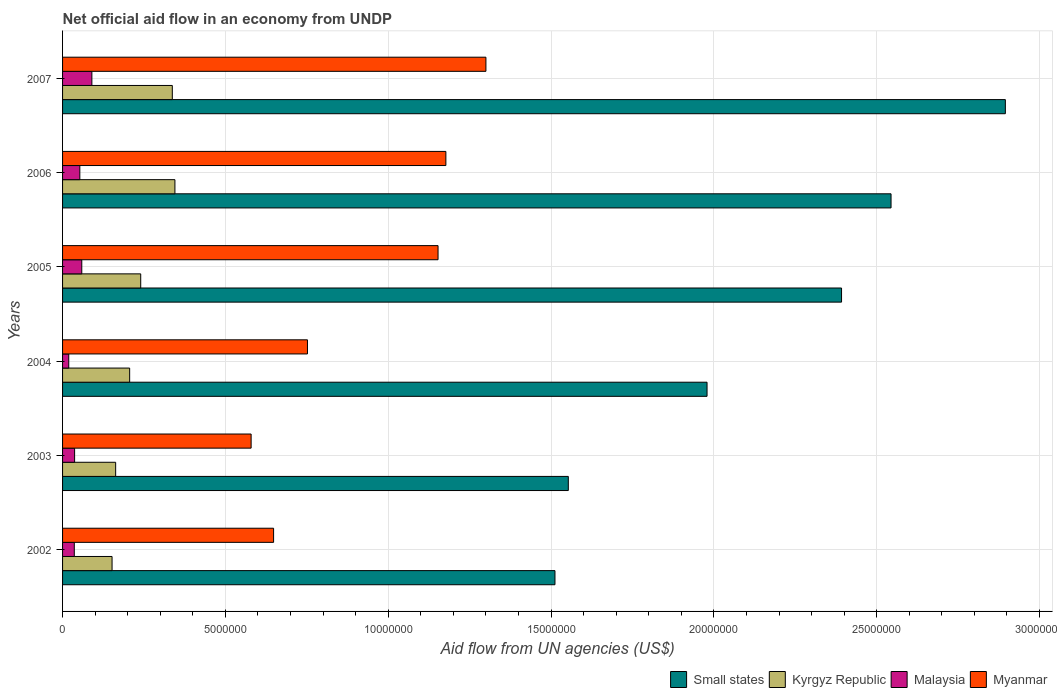How many bars are there on the 6th tick from the top?
Keep it short and to the point. 4. What is the label of the 6th group of bars from the top?
Provide a short and direct response. 2002. In how many cases, is the number of bars for a given year not equal to the number of legend labels?
Give a very brief answer. 0. What is the net official aid flow in Myanmar in 2003?
Provide a succinct answer. 5.79e+06. Across all years, what is the maximum net official aid flow in Kyrgyz Republic?
Your answer should be very brief. 3.45e+06. Across all years, what is the minimum net official aid flow in Kyrgyz Republic?
Offer a terse response. 1.52e+06. In which year was the net official aid flow in Small states maximum?
Your answer should be very brief. 2007. In which year was the net official aid flow in Kyrgyz Republic minimum?
Your answer should be compact. 2002. What is the total net official aid flow in Malaysia in the graph?
Keep it short and to the point. 2.94e+06. What is the difference between the net official aid flow in Kyrgyz Republic in 2004 and that in 2007?
Offer a very short reply. -1.31e+06. What is the difference between the net official aid flow in Malaysia in 2005 and the net official aid flow in Myanmar in 2003?
Offer a very short reply. -5.20e+06. In the year 2003, what is the difference between the net official aid flow in Malaysia and net official aid flow in Small states?
Make the answer very short. -1.52e+07. In how many years, is the net official aid flow in Myanmar greater than 25000000 US$?
Provide a short and direct response. 0. What is the ratio of the net official aid flow in Kyrgyz Republic in 2005 to that in 2006?
Your answer should be very brief. 0.7. Is the net official aid flow in Myanmar in 2003 less than that in 2004?
Keep it short and to the point. Yes. What is the difference between the highest and the second highest net official aid flow in Myanmar?
Your answer should be compact. 1.23e+06. What is the difference between the highest and the lowest net official aid flow in Kyrgyz Republic?
Ensure brevity in your answer.  1.93e+06. Is the sum of the net official aid flow in Malaysia in 2003 and 2006 greater than the maximum net official aid flow in Kyrgyz Republic across all years?
Give a very brief answer. No. What does the 3rd bar from the top in 2005 represents?
Give a very brief answer. Kyrgyz Republic. What does the 1st bar from the bottom in 2006 represents?
Make the answer very short. Small states. Is it the case that in every year, the sum of the net official aid flow in Small states and net official aid flow in Kyrgyz Republic is greater than the net official aid flow in Myanmar?
Give a very brief answer. Yes. How many bars are there?
Keep it short and to the point. 24. What is the difference between two consecutive major ticks on the X-axis?
Give a very brief answer. 5.00e+06. Does the graph contain any zero values?
Your response must be concise. No. Does the graph contain grids?
Provide a succinct answer. Yes. What is the title of the graph?
Make the answer very short. Net official aid flow in an economy from UNDP. What is the label or title of the X-axis?
Provide a short and direct response. Aid flow from UN agencies (US$). What is the label or title of the Y-axis?
Ensure brevity in your answer.  Years. What is the Aid flow from UN agencies (US$) of Small states in 2002?
Offer a terse response. 1.51e+07. What is the Aid flow from UN agencies (US$) of Kyrgyz Republic in 2002?
Make the answer very short. 1.52e+06. What is the Aid flow from UN agencies (US$) in Malaysia in 2002?
Offer a very short reply. 3.60e+05. What is the Aid flow from UN agencies (US$) in Myanmar in 2002?
Give a very brief answer. 6.48e+06. What is the Aid flow from UN agencies (US$) of Small states in 2003?
Provide a succinct answer. 1.55e+07. What is the Aid flow from UN agencies (US$) of Kyrgyz Republic in 2003?
Provide a short and direct response. 1.63e+06. What is the Aid flow from UN agencies (US$) in Myanmar in 2003?
Give a very brief answer. 5.79e+06. What is the Aid flow from UN agencies (US$) of Small states in 2004?
Your answer should be compact. 1.98e+07. What is the Aid flow from UN agencies (US$) in Kyrgyz Republic in 2004?
Give a very brief answer. 2.06e+06. What is the Aid flow from UN agencies (US$) in Malaysia in 2004?
Ensure brevity in your answer.  1.90e+05. What is the Aid flow from UN agencies (US$) of Myanmar in 2004?
Provide a succinct answer. 7.52e+06. What is the Aid flow from UN agencies (US$) in Small states in 2005?
Ensure brevity in your answer.  2.39e+07. What is the Aid flow from UN agencies (US$) in Kyrgyz Republic in 2005?
Offer a terse response. 2.40e+06. What is the Aid flow from UN agencies (US$) in Malaysia in 2005?
Offer a very short reply. 5.90e+05. What is the Aid flow from UN agencies (US$) of Myanmar in 2005?
Your answer should be compact. 1.15e+07. What is the Aid flow from UN agencies (US$) in Small states in 2006?
Give a very brief answer. 2.54e+07. What is the Aid flow from UN agencies (US$) of Kyrgyz Republic in 2006?
Provide a short and direct response. 3.45e+06. What is the Aid flow from UN agencies (US$) of Malaysia in 2006?
Your response must be concise. 5.30e+05. What is the Aid flow from UN agencies (US$) in Myanmar in 2006?
Offer a terse response. 1.18e+07. What is the Aid flow from UN agencies (US$) of Small states in 2007?
Your response must be concise. 2.90e+07. What is the Aid flow from UN agencies (US$) in Kyrgyz Republic in 2007?
Your response must be concise. 3.37e+06. What is the Aid flow from UN agencies (US$) in Malaysia in 2007?
Keep it short and to the point. 9.00e+05. What is the Aid flow from UN agencies (US$) in Myanmar in 2007?
Your answer should be compact. 1.30e+07. Across all years, what is the maximum Aid flow from UN agencies (US$) of Small states?
Your answer should be very brief. 2.90e+07. Across all years, what is the maximum Aid flow from UN agencies (US$) in Kyrgyz Republic?
Give a very brief answer. 3.45e+06. Across all years, what is the maximum Aid flow from UN agencies (US$) of Myanmar?
Offer a terse response. 1.30e+07. Across all years, what is the minimum Aid flow from UN agencies (US$) in Small states?
Offer a terse response. 1.51e+07. Across all years, what is the minimum Aid flow from UN agencies (US$) in Kyrgyz Republic?
Your response must be concise. 1.52e+06. Across all years, what is the minimum Aid flow from UN agencies (US$) in Myanmar?
Give a very brief answer. 5.79e+06. What is the total Aid flow from UN agencies (US$) of Small states in the graph?
Make the answer very short. 1.29e+08. What is the total Aid flow from UN agencies (US$) in Kyrgyz Republic in the graph?
Provide a short and direct response. 1.44e+07. What is the total Aid flow from UN agencies (US$) of Malaysia in the graph?
Your response must be concise. 2.94e+06. What is the total Aid flow from UN agencies (US$) of Myanmar in the graph?
Keep it short and to the point. 5.61e+07. What is the difference between the Aid flow from UN agencies (US$) of Small states in 2002 and that in 2003?
Offer a very short reply. -4.10e+05. What is the difference between the Aid flow from UN agencies (US$) of Kyrgyz Republic in 2002 and that in 2003?
Offer a terse response. -1.10e+05. What is the difference between the Aid flow from UN agencies (US$) of Malaysia in 2002 and that in 2003?
Make the answer very short. -10000. What is the difference between the Aid flow from UN agencies (US$) in Myanmar in 2002 and that in 2003?
Your response must be concise. 6.90e+05. What is the difference between the Aid flow from UN agencies (US$) in Small states in 2002 and that in 2004?
Your answer should be very brief. -4.67e+06. What is the difference between the Aid flow from UN agencies (US$) of Kyrgyz Republic in 2002 and that in 2004?
Keep it short and to the point. -5.40e+05. What is the difference between the Aid flow from UN agencies (US$) of Myanmar in 2002 and that in 2004?
Offer a very short reply. -1.04e+06. What is the difference between the Aid flow from UN agencies (US$) in Small states in 2002 and that in 2005?
Your answer should be compact. -8.80e+06. What is the difference between the Aid flow from UN agencies (US$) in Kyrgyz Republic in 2002 and that in 2005?
Give a very brief answer. -8.80e+05. What is the difference between the Aid flow from UN agencies (US$) of Myanmar in 2002 and that in 2005?
Ensure brevity in your answer.  -5.05e+06. What is the difference between the Aid flow from UN agencies (US$) in Small states in 2002 and that in 2006?
Offer a very short reply. -1.03e+07. What is the difference between the Aid flow from UN agencies (US$) of Kyrgyz Republic in 2002 and that in 2006?
Offer a terse response. -1.93e+06. What is the difference between the Aid flow from UN agencies (US$) of Malaysia in 2002 and that in 2006?
Provide a succinct answer. -1.70e+05. What is the difference between the Aid flow from UN agencies (US$) in Myanmar in 2002 and that in 2006?
Make the answer very short. -5.29e+06. What is the difference between the Aid flow from UN agencies (US$) of Small states in 2002 and that in 2007?
Ensure brevity in your answer.  -1.38e+07. What is the difference between the Aid flow from UN agencies (US$) in Kyrgyz Republic in 2002 and that in 2007?
Ensure brevity in your answer.  -1.85e+06. What is the difference between the Aid flow from UN agencies (US$) in Malaysia in 2002 and that in 2007?
Offer a terse response. -5.40e+05. What is the difference between the Aid flow from UN agencies (US$) of Myanmar in 2002 and that in 2007?
Provide a succinct answer. -6.52e+06. What is the difference between the Aid flow from UN agencies (US$) of Small states in 2003 and that in 2004?
Give a very brief answer. -4.26e+06. What is the difference between the Aid flow from UN agencies (US$) of Kyrgyz Republic in 2003 and that in 2004?
Offer a terse response. -4.30e+05. What is the difference between the Aid flow from UN agencies (US$) of Myanmar in 2003 and that in 2004?
Offer a terse response. -1.73e+06. What is the difference between the Aid flow from UN agencies (US$) in Small states in 2003 and that in 2005?
Your answer should be very brief. -8.39e+06. What is the difference between the Aid flow from UN agencies (US$) in Kyrgyz Republic in 2003 and that in 2005?
Make the answer very short. -7.70e+05. What is the difference between the Aid flow from UN agencies (US$) in Myanmar in 2003 and that in 2005?
Your response must be concise. -5.74e+06. What is the difference between the Aid flow from UN agencies (US$) of Small states in 2003 and that in 2006?
Keep it short and to the point. -9.91e+06. What is the difference between the Aid flow from UN agencies (US$) of Kyrgyz Republic in 2003 and that in 2006?
Provide a succinct answer. -1.82e+06. What is the difference between the Aid flow from UN agencies (US$) of Myanmar in 2003 and that in 2006?
Your response must be concise. -5.98e+06. What is the difference between the Aid flow from UN agencies (US$) of Small states in 2003 and that in 2007?
Offer a very short reply. -1.34e+07. What is the difference between the Aid flow from UN agencies (US$) in Kyrgyz Republic in 2003 and that in 2007?
Make the answer very short. -1.74e+06. What is the difference between the Aid flow from UN agencies (US$) in Malaysia in 2003 and that in 2007?
Keep it short and to the point. -5.30e+05. What is the difference between the Aid flow from UN agencies (US$) of Myanmar in 2003 and that in 2007?
Provide a succinct answer. -7.21e+06. What is the difference between the Aid flow from UN agencies (US$) of Small states in 2004 and that in 2005?
Keep it short and to the point. -4.13e+06. What is the difference between the Aid flow from UN agencies (US$) of Malaysia in 2004 and that in 2005?
Provide a short and direct response. -4.00e+05. What is the difference between the Aid flow from UN agencies (US$) in Myanmar in 2004 and that in 2005?
Your response must be concise. -4.01e+06. What is the difference between the Aid flow from UN agencies (US$) of Small states in 2004 and that in 2006?
Your answer should be very brief. -5.65e+06. What is the difference between the Aid flow from UN agencies (US$) in Kyrgyz Republic in 2004 and that in 2006?
Your response must be concise. -1.39e+06. What is the difference between the Aid flow from UN agencies (US$) in Malaysia in 2004 and that in 2006?
Provide a short and direct response. -3.40e+05. What is the difference between the Aid flow from UN agencies (US$) of Myanmar in 2004 and that in 2006?
Make the answer very short. -4.25e+06. What is the difference between the Aid flow from UN agencies (US$) in Small states in 2004 and that in 2007?
Provide a short and direct response. -9.16e+06. What is the difference between the Aid flow from UN agencies (US$) of Kyrgyz Republic in 2004 and that in 2007?
Your answer should be compact. -1.31e+06. What is the difference between the Aid flow from UN agencies (US$) of Malaysia in 2004 and that in 2007?
Your answer should be compact. -7.10e+05. What is the difference between the Aid flow from UN agencies (US$) in Myanmar in 2004 and that in 2007?
Provide a short and direct response. -5.48e+06. What is the difference between the Aid flow from UN agencies (US$) of Small states in 2005 and that in 2006?
Ensure brevity in your answer.  -1.52e+06. What is the difference between the Aid flow from UN agencies (US$) in Kyrgyz Republic in 2005 and that in 2006?
Your answer should be very brief. -1.05e+06. What is the difference between the Aid flow from UN agencies (US$) in Malaysia in 2005 and that in 2006?
Your response must be concise. 6.00e+04. What is the difference between the Aid flow from UN agencies (US$) of Myanmar in 2005 and that in 2006?
Provide a short and direct response. -2.40e+05. What is the difference between the Aid flow from UN agencies (US$) in Small states in 2005 and that in 2007?
Offer a terse response. -5.03e+06. What is the difference between the Aid flow from UN agencies (US$) in Kyrgyz Republic in 2005 and that in 2007?
Your answer should be very brief. -9.70e+05. What is the difference between the Aid flow from UN agencies (US$) in Malaysia in 2005 and that in 2007?
Keep it short and to the point. -3.10e+05. What is the difference between the Aid flow from UN agencies (US$) of Myanmar in 2005 and that in 2007?
Give a very brief answer. -1.47e+06. What is the difference between the Aid flow from UN agencies (US$) of Small states in 2006 and that in 2007?
Provide a succinct answer. -3.51e+06. What is the difference between the Aid flow from UN agencies (US$) in Kyrgyz Republic in 2006 and that in 2007?
Ensure brevity in your answer.  8.00e+04. What is the difference between the Aid flow from UN agencies (US$) in Malaysia in 2006 and that in 2007?
Your answer should be very brief. -3.70e+05. What is the difference between the Aid flow from UN agencies (US$) of Myanmar in 2006 and that in 2007?
Your answer should be very brief. -1.23e+06. What is the difference between the Aid flow from UN agencies (US$) in Small states in 2002 and the Aid flow from UN agencies (US$) in Kyrgyz Republic in 2003?
Provide a succinct answer. 1.35e+07. What is the difference between the Aid flow from UN agencies (US$) in Small states in 2002 and the Aid flow from UN agencies (US$) in Malaysia in 2003?
Offer a very short reply. 1.48e+07. What is the difference between the Aid flow from UN agencies (US$) in Small states in 2002 and the Aid flow from UN agencies (US$) in Myanmar in 2003?
Keep it short and to the point. 9.33e+06. What is the difference between the Aid flow from UN agencies (US$) in Kyrgyz Republic in 2002 and the Aid flow from UN agencies (US$) in Malaysia in 2003?
Ensure brevity in your answer.  1.15e+06. What is the difference between the Aid flow from UN agencies (US$) of Kyrgyz Republic in 2002 and the Aid flow from UN agencies (US$) of Myanmar in 2003?
Provide a short and direct response. -4.27e+06. What is the difference between the Aid flow from UN agencies (US$) of Malaysia in 2002 and the Aid flow from UN agencies (US$) of Myanmar in 2003?
Offer a terse response. -5.43e+06. What is the difference between the Aid flow from UN agencies (US$) of Small states in 2002 and the Aid flow from UN agencies (US$) of Kyrgyz Republic in 2004?
Your response must be concise. 1.31e+07. What is the difference between the Aid flow from UN agencies (US$) in Small states in 2002 and the Aid flow from UN agencies (US$) in Malaysia in 2004?
Your answer should be very brief. 1.49e+07. What is the difference between the Aid flow from UN agencies (US$) in Small states in 2002 and the Aid flow from UN agencies (US$) in Myanmar in 2004?
Your response must be concise. 7.60e+06. What is the difference between the Aid flow from UN agencies (US$) in Kyrgyz Republic in 2002 and the Aid flow from UN agencies (US$) in Malaysia in 2004?
Ensure brevity in your answer.  1.33e+06. What is the difference between the Aid flow from UN agencies (US$) in Kyrgyz Republic in 2002 and the Aid flow from UN agencies (US$) in Myanmar in 2004?
Provide a short and direct response. -6.00e+06. What is the difference between the Aid flow from UN agencies (US$) in Malaysia in 2002 and the Aid flow from UN agencies (US$) in Myanmar in 2004?
Your answer should be very brief. -7.16e+06. What is the difference between the Aid flow from UN agencies (US$) of Small states in 2002 and the Aid flow from UN agencies (US$) of Kyrgyz Republic in 2005?
Offer a terse response. 1.27e+07. What is the difference between the Aid flow from UN agencies (US$) of Small states in 2002 and the Aid flow from UN agencies (US$) of Malaysia in 2005?
Your answer should be very brief. 1.45e+07. What is the difference between the Aid flow from UN agencies (US$) of Small states in 2002 and the Aid flow from UN agencies (US$) of Myanmar in 2005?
Your response must be concise. 3.59e+06. What is the difference between the Aid flow from UN agencies (US$) of Kyrgyz Republic in 2002 and the Aid flow from UN agencies (US$) of Malaysia in 2005?
Keep it short and to the point. 9.30e+05. What is the difference between the Aid flow from UN agencies (US$) of Kyrgyz Republic in 2002 and the Aid flow from UN agencies (US$) of Myanmar in 2005?
Provide a short and direct response. -1.00e+07. What is the difference between the Aid flow from UN agencies (US$) in Malaysia in 2002 and the Aid flow from UN agencies (US$) in Myanmar in 2005?
Offer a terse response. -1.12e+07. What is the difference between the Aid flow from UN agencies (US$) of Small states in 2002 and the Aid flow from UN agencies (US$) of Kyrgyz Republic in 2006?
Give a very brief answer. 1.17e+07. What is the difference between the Aid flow from UN agencies (US$) in Small states in 2002 and the Aid flow from UN agencies (US$) in Malaysia in 2006?
Offer a terse response. 1.46e+07. What is the difference between the Aid flow from UN agencies (US$) of Small states in 2002 and the Aid flow from UN agencies (US$) of Myanmar in 2006?
Make the answer very short. 3.35e+06. What is the difference between the Aid flow from UN agencies (US$) of Kyrgyz Republic in 2002 and the Aid flow from UN agencies (US$) of Malaysia in 2006?
Offer a terse response. 9.90e+05. What is the difference between the Aid flow from UN agencies (US$) of Kyrgyz Republic in 2002 and the Aid flow from UN agencies (US$) of Myanmar in 2006?
Provide a short and direct response. -1.02e+07. What is the difference between the Aid flow from UN agencies (US$) in Malaysia in 2002 and the Aid flow from UN agencies (US$) in Myanmar in 2006?
Give a very brief answer. -1.14e+07. What is the difference between the Aid flow from UN agencies (US$) in Small states in 2002 and the Aid flow from UN agencies (US$) in Kyrgyz Republic in 2007?
Your answer should be very brief. 1.18e+07. What is the difference between the Aid flow from UN agencies (US$) of Small states in 2002 and the Aid flow from UN agencies (US$) of Malaysia in 2007?
Provide a short and direct response. 1.42e+07. What is the difference between the Aid flow from UN agencies (US$) in Small states in 2002 and the Aid flow from UN agencies (US$) in Myanmar in 2007?
Keep it short and to the point. 2.12e+06. What is the difference between the Aid flow from UN agencies (US$) of Kyrgyz Republic in 2002 and the Aid flow from UN agencies (US$) of Malaysia in 2007?
Make the answer very short. 6.20e+05. What is the difference between the Aid flow from UN agencies (US$) of Kyrgyz Republic in 2002 and the Aid flow from UN agencies (US$) of Myanmar in 2007?
Your answer should be compact. -1.15e+07. What is the difference between the Aid flow from UN agencies (US$) in Malaysia in 2002 and the Aid flow from UN agencies (US$) in Myanmar in 2007?
Your response must be concise. -1.26e+07. What is the difference between the Aid flow from UN agencies (US$) in Small states in 2003 and the Aid flow from UN agencies (US$) in Kyrgyz Republic in 2004?
Give a very brief answer. 1.35e+07. What is the difference between the Aid flow from UN agencies (US$) in Small states in 2003 and the Aid flow from UN agencies (US$) in Malaysia in 2004?
Your response must be concise. 1.53e+07. What is the difference between the Aid flow from UN agencies (US$) in Small states in 2003 and the Aid flow from UN agencies (US$) in Myanmar in 2004?
Offer a very short reply. 8.01e+06. What is the difference between the Aid flow from UN agencies (US$) in Kyrgyz Republic in 2003 and the Aid flow from UN agencies (US$) in Malaysia in 2004?
Provide a short and direct response. 1.44e+06. What is the difference between the Aid flow from UN agencies (US$) in Kyrgyz Republic in 2003 and the Aid flow from UN agencies (US$) in Myanmar in 2004?
Offer a very short reply. -5.89e+06. What is the difference between the Aid flow from UN agencies (US$) in Malaysia in 2003 and the Aid flow from UN agencies (US$) in Myanmar in 2004?
Offer a terse response. -7.15e+06. What is the difference between the Aid flow from UN agencies (US$) of Small states in 2003 and the Aid flow from UN agencies (US$) of Kyrgyz Republic in 2005?
Your answer should be very brief. 1.31e+07. What is the difference between the Aid flow from UN agencies (US$) in Small states in 2003 and the Aid flow from UN agencies (US$) in Malaysia in 2005?
Your answer should be very brief. 1.49e+07. What is the difference between the Aid flow from UN agencies (US$) in Kyrgyz Republic in 2003 and the Aid flow from UN agencies (US$) in Malaysia in 2005?
Your response must be concise. 1.04e+06. What is the difference between the Aid flow from UN agencies (US$) of Kyrgyz Republic in 2003 and the Aid flow from UN agencies (US$) of Myanmar in 2005?
Provide a short and direct response. -9.90e+06. What is the difference between the Aid flow from UN agencies (US$) of Malaysia in 2003 and the Aid flow from UN agencies (US$) of Myanmar in 2005?
Ensure brevity in your answer.  -1.12e+07. What is the difference between the Aid flow from UN agencies (US$) in Small states in 2003 and the Aid flow from UN agencies (US$) in Kyrgyz Republic in 2006?
Give a very brief answer. 1.21e+07. What is the difference between the Aid flow from UN agencies (US$) of Small states in 2003 and the Aid flow from UN agencies (US$) of Malaysia in 2006?
Give a very brief answer. 1.50e+07. What is the difference between the Aid flow from UN agencies (US$) in Small states in 2003 and the Aid flow from UN agencies (US$) in Myanmar in 2006?
Your response must be concise. 3.76e+06. What is the difference between the Aid flow from UN agencies (US$) in Kyrgyz Republic in 2003 and the Aid flow from UN agencies (US$) in Malaysia in 2006?
Ensure brevity in your answer.  1.10e+06. What is the difference between the Aid flow from UN agencies (US$) of Kyrgyz Republic in 2003 and the Aid flow from UN agencies (US$) of Myanmar in 2006?
Ensure brevity in your answer.  -1.01e+07. What is the difference between the Aid flow from UN agencies (US$) of Malaysia in 2003 and the Aid flow from UN agencies (US$) of Myanmar in 2006?
Your response must be concise. -1.14e+07. What is the difference between the Aid flow from UN agencies (US$) of Small states in 2003 and the Aid flow from UN agencies (US$) of Kyrgyz Republic in 2007?
Provide a succinct answer. 1.22e+07. What is the difference between the Aid flow from UN agencies (US$) of Small states in 2003 and the Aid flow from UN agencies (US$) of Malaysia in 2007?
Your answer should be very brief. 1.46e+07. What is the difference between the Aid flow from UN agencies (US$) in Small states in 2003 and the Aid flow from UN agencies (US$) in Myanmar in 2007?
Give a very brief answer. 2.53e+06. What is the difference between the Aid flow from UN agencies (US$) of Kyrgyz Republic in 2003 and the Aid flow from UN agencies (US$) of Malaysia in 2007?
Offer a very short reply. 7.30e+05. What is the difference between the Aid flow from UN agencies (US$) in Kyrgyz Republic in 2003 and the Aid flow from UN agencies (US$) in Myanmar in 2007?
Ensure brevity in your answer.  -1.14e+07. What is the difference between the Aid flow from UN agencies (US$) in Malaysia in 2003 and the Aid flow from UN agencies (US$) in Myanmar in 2007?
Offer a terse response. -1.26e+07. What is the difference between the Aid flow from UN agencies (US$) in Small states in 2004 and the Aid flow from UN agencies (US$) in Kyrgyz Republic in 2005?
Make the answer very short. 1.74e+07. What is the difference between the Aid flow from UN agencies (US$) of Small states in 2004 and the Aid flow from UN agencies (US$) of Malaysia in 2005?
Offer a very short reply. 1.92e+07. What is the difference between the Aid flow from UN agencies (US$) in Small states in 2004 and the Aid flow from UN agencies (US$) in Myanmar in 2005?
Keep it short and to the point. 8.26e+06. What is the difference between the Aid flow from UN agencies (US$) in Kyrgyz Republic in 2004 and the Aid flow from UN agencies (US$) in Malaysia in 2005?
Offer a terse response. 1.47e+06. What is the difference between the Aid flow from UN agencies (US$) of Kyrgyz Republic in 2004 and the Aid flow from UN agencies (US$) of Myanmar in 2005?
Your answer should be compact. -9.47e+06. What is the difference between the Aid flow from UN agencies (US$) of Malaysia in 2004 and the Aid flow from UN agencies (US$) of Myanmar in 2005?
Make the answer very short. -1.13e+07. What is the difference between the Aid flow from UN agencies (US$) in Small states in 2004 and the Aid flow from UN agencies (US$) in Kyrgyz Republic in 2006?
Keep it short and to the point. 1.63e+07. What is the difference between the Aid flow from UN agencies (US$) of Small states in 2004 and the Aid flow from UN agencies (US$) of Malaysia in 2006?
Give a very brief answer. 1.93e+07. What is the difference between the Aid flow from UN agencies (US$) in Small states in 2004 and the Aid flow from UN agencies (US$) in Myanmar in 2006?
Provide a succinct answer. 8.02e+06. What is the difference between the Aid flow from UN agencies (US$) of Kyrgyz Republic in 2004 and the Aid flow from UN agencies (US$) of Malaysia in 2006?
Offer a terse response. 1.53e+06. What is the difference between the Aid flow from UN agencies (US$) of Kyrgyz Republic in 2004 and the Aid flow from UN agencies (US$) of Myanmar in 2006?
Provide a short and direct response. -9.71e+06. What is the difference between the Aid flow from UN agencies (US$) in Malaysia in 2004 and the Aid flow from UN agencies (US$) in Myanmar in 2006?
Offer a very short reply. -1.16e+07. What is the difference between the Aid flow from UN agencies (US$) of Small states in 2004 and the Aid flow from UN agencies (US$) of Kyrgyz Republic in 2007?
Offer a very short reply. 1.64e+07. What is the difference between the Aid flow from UN agencies (US$) in Small states in 2004 and the Aid flow from UN agencies (US$) in Malaysia in 2007?
Offer a terse response. 1.89e+07. What is the difference between the Aid flow from UN agencies (US$) of Small states in 2004 and the Aid flow from UN agencies (US$) of Myanmar in 2007?
Offer a terse response. 6.79e+06. What is the difference between the Aid flow from UN agencies (US$) in Kyrgyz Republic in 2004 and the Aid flow from UN agencies (US$) in Malaysia in 2007?
Provide a short and direct response. 1.16e+06. What is the difference between the Aid flow from UN agencies (US$) of Kyrgyz Republic in 2004 and the Aid flow from UN agencies (US$) of Myanmar in 2007?
Your answer should be very brief. -1.09e+07. What is the difference between the Aid flow from UN agencies (US$) in Malaysia in 2004 and the Aid flow from UN agencies (US$) in Myanmar in 2007?
Ensure brevity in your answer.  -1.28e+07. What is the difference between the Aid flow from UN agencies (US$) of Small states in 2005 and the Aid flow from UN agencies (US$) of Kyrgyz Republic in 2006?
Make the answer very short. 2.05e+07. What is the difference between the Aid flow from UN agencies (US$) of Small states in 2005 and the Aid flow from UN agencies (US$) of Malaysia in 2006?
Give a very brief answer. 2.34e+07. What is the difference between the Aid flow from UN agencies (US$) of Small states in 2005 and the Aid flow from UN agencies (US$) of Myanmar in 2006?
Your answer should be very brief. 1.22e+07. What is the difference between the Aid flow from UN agencies (US$) in Kyrgyz Republic in 2005 and the Aid flow from UN agencies (US$) in Malaysia in 2006?
Keep it short and to the point. 1.87e+06. What is the difference between the Aid flow from UN agencies (US$) of Kyrgyz Republic in 2005 and the Aid flow from UN agencies (US$) of Myanmar in 2006?
Your answer should be very brief. -9.37e+06. What is the difference between the Aid flow from UN agencies (US$) in Malaysia in 2005 and the Aid flow from UN agencies (US$) in Myanmar in 2006?
Your response must be concise. -1.12e+07. What is the difference between the Aid flow from UN agencies (US$) of Small states in 2005 and the Aid flow from UN agencies (US$) of Kyrgyz Republic in 2007?
Give a very brief answer. 2.06e+07. What is the difference between the Aid flow from UN agencies (US$) in Small states in 2005 and the Aid flow from UN agencies (US$) in Malaysia in 2007?
Your answer should be compact. 2.30e+07. What is the difference between the Aid flow from UN agencies (US$) in Small states in 2005 and the Aid flow from UN agencies (US$) in Myanmar in 2007?
Your answer should be compact. 1.09e+07. What is the difference between the Aid flow from UN agencies (US$) of Kyrgyz Republic in 2005 and the Aid flow from UN agencies (US$) of Malaysia in 2007?
Keep it short and to the point. 1.50e+06. What is the difference between the Aid flow from UN agencies (US$) of Kyrgyz Republic in 2005 and the Aid flow from UN agencies (US$) of Myanmar in 2007?
Your answer should be very brief. -1.06e+07. What is the difference between the Aid flow from UN agencies (US$) of Malaysia in 2005 and the Aid flow from UN agencies (US$) of Myanmar in 2007?
Offer a very short reply. -1.24e+07. What is the difference between the Aid flow from UN agencies (US$) of Small states in 2006 and the Aid flow from UN agencies (US$) of Kyrgyz Republic in 2007?
Keep it short and to the point. 2.21e+07. What is the difference between the Aid flow from UN agencies (US$) in Small states in 2006 and the Aid flow from UN agencies (US$) in Malaysia in 2007?
Keep it short and to the point. 2.45e+07. What is the difference between the Aid flow from UN agencies (US$) in Small states in 2006 and the Aid flow from UN agencies (US$) in Myanmar in 2007?
Provide a short and direct response. 1.24e+07. What is the difference between the Aid flow from UN agencies (US$) of Kyrgyz Republic in 2006 and the Aid flow from UN agencies (US$) of Malaysia in 2007?
Make the answer very short. 2.55e+06. What is the difference between the Aid flow from UN agencies (US$) of Kyrgyz Republic in 2006 and the Aid flow from UN agencies (US$) of Myanmar in 2007?
Offer a terse response. -9.55e+06. What is the difference between the Aid flow from UN agencies (US$) in Malaysia in 2006 and the Aid flow from UN agencies (US$) in Myanmar in 2007?
Ensure brevity in your answer.  -1.25e+07. What is the average Aid flow from UN agencies (US$) in Small states per year?
Give a very brief answer. 2.15e+07. What is the average Aid flow from UN agencies (US$) of Kyrgyz Republic per year?
Your answer should be compact. 2.40e+06. What is the average Aid flow from UN agencies (US$) in Myanmar per year?
Provide a short and direct response. 9.35e+06. In the year 2002, what is the difference between the Aid flow from UN agencies (US$) of Small states and Aid flow from UN agencies (US$) of Kyrgyz Republic?
Your answer should be very brief. 1.36e+07. In the year 2002, what is the difference between the Aid flow from UN agencies (US$) of Small states and Aid flow from UN agencies (US$) of Malaysia?
Offer a very short reply. 1.48e+07. In the year 2002, what is the difference between the Aid flow from UN agencies (US$) of Small states and Aid flow from UN agencies (US$) of Myanmar?
Your answer should be compact. 8.64e+06. In the year 2002, what is the difference between the Aid flow from UN agencies (US$) of Kyrgyz Republic and Aid flow from UN agencies (US$) of Malaysia?
Provide a short and direct response. 1.16e+06. In the year 2002, what is the difference between the Aid flow from UN agencies (US$) in Kyrgyz Republic and Aid flow from UN agencies (US$) in Myanmar?
Provide a succinct answer. -4.96e+06. In the year 2002, what is the difference between the Aid flow from UN agencies (US$) of Malaysia and Aid flow from UN agencies (US$) of Myanmar?
Keep it short and to the point. -6.12e+06. In the year 2003, what is the difference between the Aid flow from UN agencies (US$) in Small states and Aid flow from UN agencies (US$) in Kyrgyz Republic?
Keep it short and to the point. 1.39e+07. In the year 2003, what is the difference between the Aid flow from UN agencies (US$) of Small states and Aid flow from UN agencies (US$) of Malaysia?
Your answer should be very brief. 1.52e+07. In the year 2003, what is the difference between the Aid flow from UN agencies (US$) in Small states and Aid flow from UN agencies (US$) in Myanmar?
Make the answer very short. 9.74e+06. In the year 2003, what is the difference between the Aid flow from UN agencies (US$) in Kyrgyz Republic and Aid flow from UN agencies (US$) in Malaysia?
Offer a terse response. 1.26e+06. In the year 2003, what is the difference between the Aid flow from UN agencies (US$) of Kyrgyz Republic and Aid flow from UN agencies (US$) of Myanmar?
Your answer should be compact. -4.16e+06. In the year 2003, what is the difference between the Aid flow from UN agencies (US$) in Malaysia and Aid flow from UN agencies (US$) in Myanmar?
Offer a terse response. -5.42e+06. In the year 2004, what is the difference between the Aid flow from UN agencies (US$) of Small states and Aid flow from UN agencies (US$) of Kyrgyz Republic?
Keep it short and to the point. 1.77e+07. In the year 2004, what is the difference between the Aid flow from UN agencies (US$) of Small states and Aid flow from UN agencies (US$) of Malaysia?
Your response must be concise. 1.96e+07. In the year 2004, what is the difference between the Aid flow from UN agencies (US$) in Small states and Aid flow from UN agencies (US$) in Myanmar?
Provide a succinct answer. 1.23e+07. In the year 2004, what is the difference between the Aid flow from UN agencies (US$) of Kyrgyz Republic and Aid flow from UN agencies (US$) of Malaysia?
Give a very brief answer. 1.87e+06. In the year 2004, what is the difference between the Aid flow from UN agencies (US$) of Kyrgyz Republic and Aid flow from UN agencies (US$) of Myanmar?
Give a very brief answer. -5.46e+06. In the year 2004, what is the difference between the Aid flow from UN agencies (US$) of Malaysia and Aid flow from UN agencies (US$) of Myanmar?
Provide a succinct answer. -7.33e+06. In the year 2005, what is the difference between the Aid flow from UN agencies (US$) in Small states and Aid flow from UN agencies (US$) in Kyrgyz Republic?
Offer a terse response. 2.15e+07. In the year 2005, what is the difference between the Aid flow from UN agencies (US$) in Small states and Aid flow from UN agencies (US$) in Malaysia?
Offer a very short reply. 2.33e+07. In the year 2005, what is the difference between the Aid flow from UN agencies (US$) in Small states and Aid flow from UN agencies (US$) in Myanmar?
Provide a short and direct response. 1.24e+07. In the year 2005, what is the difference between the Aid flow from UN agencies (US$) in Kyrgyz Republic and Aid flow from UN agencies (US$) in Malaysia?
Your answer should be compact. 1.81e+06. In the year 2005, what is the difference between the Aid flow from UN agencies (US$) of Kyrgyz Republic and Aid flow from UN agencies (US$) of Myanmar?
Provide a short and direct response. -9.13e+06. In the year 2005, what is the difference between the Aid flow from UN agencies (US$) in Malaysia and Aid flow from UN agencies (US$) in Myanmar?
Provide a succinct answer. -1.09e+07. In the year 2006, what is the difference between the Aid flow from UN agencies (US$) of Small states and Aid flow from UN agencies (US$) of Kyrgyz Republic?
Your answer should be compact. 2.20e+07. In the year 2006, what is the difference between the Aid flow from UN agencies (US$) of Small states and Aid flow from UN agencies (US$) of Malaysia?
Offer a very short reply. 2.49e+07. In the year 2006, what is the difference between the Aid flow from UN agencies (US$) of Small states and Aid flow from UN agencies (US$) of Myanmar?
Make the answer very short. 1.37e+07. In the year 2006, what is the difference between the Aid flow from UN agencies (US$) of Kyrgyz Republic and Aid flow from UN agencies (US$) of Malaysia?
Offer a terse response. 2.92e+06. In the year 2006, what is the difference between the Aid flow from UN agencies (US$) in Kyrgyz Republic and Aid flow from UN agencies (US$) in Myanmar?
Offer a terse response. -8.32e+06. In the year 2006, what is the difference between the Aid flow from UN agencies (US$) in Malaysia and Aid flow from UN agencies (US$) in Myanmar?
Provide a succinct answer. -1.12e+07. In the year 2007, what is the difference between the Aid flow from UN agencies (US$) in Small states and Aid flow from UN agencies (US$) in Kyrgyz Republic?
Your answer should be compact. 2.56e+07. In the year 2007, what is the difference between the Aid flow from UN agencies (US$) in Small states and Aid flow from UN agencies (US$) in Malaysia?
Give a very brief answer. 2.80e+07. In the year 2007, what is the difference between the Aid flow from UN agencies (US$) of Small states and Aid flow from UN agencies (US$) of Myanmar?
Keep it short and to the point. 1.60e+07. In the year 2007, what is the difference between the Aid flow from UN agencies (US$) in Kyrgyz Republic and Aid flow from UN agencies (US$) in Malaysia?
Offer a terse response. 2.47e+06. In the year 2007, what is the difference between the Aid flow from UN agencies (US$) in Kyrgyz Republic and Aid flow from UN agencies (US$) in Myanmar?
Give a very brief answer. -9.63e+06. In the year 2007, what is the difference between the Aid flow from UN agencies (US$) in Malaysia and Aid flow from UN agencies (US$) in Myanmar?
Ensure brevity in your answer.  -1.21e+07. What is the ratio of the Aid flow from UN agencies (US$) in Small states in 2002 to that in 2003?
Your answer should be very brief. 0.97. What is the ratio of the Aid flow from UN agencies (US$) in Kyrgyz Republic in 2002 to that in 2003?
Provide a short and direct response. 0.93. What is the ratio of the Aid flow from UN agencies (US$) in Malaysia in 2002 to that in 2003?
Keep it short and to the point. 0.97. What is the ratio of the Aid flow from UN agencies (US$) in Myanmar in 2002 to that in 2003?
Ensure brevity in your answer.  1.12. What is the ratio of the Aid flow from UN agencies (US$) of Small states in 2002 to that in 2004?
Make the answer very short. 0.76. What is the ratio of the Aid flow from UN agencies (US$) in Kyrgyz Republic in 2002 to that in 2004?
Offer a very short reply. 0.74. What is the ratio of the Aid flow from UN agencies (US$) of Malaysia in 2002 to that in 2004?
Keep it short and to the point. 1.89. What is the ratio of the Aid flow from UN agencies (US$) of Myanmar in 2002 to that in 2004?
Your answer should be compact. 0.86. What is the ratio of the Aid flow from UN agencies (US$) in Small states in 2002 to that in 2005?
Offer a very short reply. 0.63. What is the ratio of the Aid flow from UN agencies (US$) in Kyrgyz Republic in 2002 to that in 2005?
Ensure brevity in your answer.  0.63. What is the ratio of the Aid flow from UN agencies (US$) of Malaysia in 2002 to that in 2005?
Offer a very short reply. 0.61. What is the ratio of the Aid flow from UN agencies (US$) in Myanmar in 2002 to that in 2005?
Your response must be concise. 0.56. What is the ratio of the Aid flow from UN agencies (US$) of Small states in 2002 to that in 2006?
Your answer should be compact. 0.59. What is the ratio of the Aid flow from UN agencies (US$) of Kyrgyz Republic in 2002 to that in 2006?
Your answer should be very brief. 0.44. What is the ratio of the Aid flow from UN agencies (US$) in Malaysia in 2002 to that in 2006?
Make the answer very short. 0.68. What is the ratio of the Aid flow from UN agencies (US$) of Myanmar in 2002 to that in 2006?
Provide a succinct answer. 0.55. What is the ratio of the Aid flow from UN agencies (US$) in Small states in 2002 to that in 2007?
Provide a succinct answer. 0.52. What is the ratio of the Aid flow from UN agencies (US$) in Kyrgyz Republic in 2002 to that in 2007?
Offer a very short reply. 0.45. What is the ratio of the Aid flow from UN agencies (US$) in Malaysia in 2002 to that in 2007?
Give a very brief answer. 0.4. What is the ratio of the Aid flow from UN agencies (US$) in Myanmar in 2002 to that in 2007?
Make the answer very short. 0.5. What is the ratio of the Aid flow from UN agencies (US$) of Small states in 2003 to that in 2004?
Provide a short and direct response. 0.78. What is the ratio of the Aid flow from UN agencies (US$) in Kyrgyz Republic in 2003 to that in 2004?
Offer a terse response. 0.79. What is the ratio of the Aid flow from UN agencies (US$) of Malaysia in 2003 to that in 2004?
Offer a terse response. 1.95. What is the ratio of the Aid flow from UN agencies (US$) in Myanmar in 2003 to that in 2004?
Provide a short and direct response. 0.77. What is the ratio of the Aid flow from UN agencies (US$) of Small states in 2003 to that in 2005?
Provide a short and direct response. 0.65. What is the ratio of the Aid flow from UN agencies (US$) of Kyrgyz Republic in 2003 to that in 2005?
Provide a short and direct response. 0.68. What is the ratio of the Aid flow from UN agencies (US$) of Malaysia in 2003 to that in 2005?
Provide a short and direct response. 0.63. What is the ratio of the Aid flow from UN agencies (US$) of Myanmar in 2003 to that in 2005?
Your answer should be compact. 0.5. What is the ratio of the Aid flow from UN agencies (US$) in Small states in 2003 to that in 2006?
Give a very brief answer. 0.61. What is the ratio of the Aid flow from UN agencies (US$) of Kyrgyz Republic in 2003 to that in 2006?
Your answer should be very brief. 0.47. What is the ratio of the Aid flow from UN agencies (US$) in Malaysia in 2003 to that in 2006?
Your answer should be compact. 0.7. What is the ratio of the Aid flow from UN agencies (US$) of Myanmar in 2003 to that in 2006?
Give a very brief answer. 0.49. What is the ratio of the Aid flow from UN agencies (US$) in Small states in 2003 to that in 2007?
Your answer should be very brief. 0.54. What is the ratio of the Aid flow from UN agencies (US$) of Kyrgyz Republic in 2003 to that in 2007?
Offer a terse response. 0.48. What is the ratio of the Aid flow from UN agencies (US$) in Malaysia in 2003 to that in 2007?
Give a very brief answer. 0.41. What is the ratio of the Aid flow from UN agencies (US$) of Myanmar in 2003 to that in 2007?
Ensure brevity in your answer.  0.45. What is the ratio of the Aid flow from UN agencies (US$) in Small states in 2004 to that in 2005?
Your answer should be very brief. 0.83. What is the ratio of the Aid flow from UN agencies (US$) of Kyrgyz Republic in 2004 to that in 2005?
Your answer should be very brief. 0.86. What is the ratio of the Aid flow from UN agencies (US$) in Malaysia in 2004 to that in 2005?
Offer a terse response. 0.32. What is the ratio of the Aid flow from UN agencies (US$) in Myanmar in 2004 to that in 2005?
Offer a very short reply. 0.65. What is the ratio of the Aid flow from UN agencies (US$) in Small states in 2004 to that in 2006?
Your answer should be compact. 0.78. What is the ratio of the Aid flow from UN agencies (US$) of Kyrgyz Republic in 2004 to that in 2006?
Your response must be concise. 0.6. What is the ratio of the Aid flow from UN agencies (US$) in Malaysia in 2004 to that in 2006?
Give a very brief answer. 0.36. What is the ratio of the Aid flow from UN agencies (US$) of Myanmar in 2004 to that in 2006?
Make the answer very short. 0.64. What is the ratio of the Aid flow from UN agencies (US$) in Small states in 2004 to that in 2007?
Ensure brevity in your answer.  0.68. What is the ratio of the Aid flow from UN agencies (US$) in Kyrgyz Republic in 2004 to that in 2007?
Ensure brevity in your answer.  0.61. What is the ratio of the Aid flow from UN agencies (US$) in Malaysia in 2004 to that in 2007?
Offer a very short reply. 0.21. What is the ratio of the Aid flow from UN agencies (US$) in Myanmar in 2004 to that in 2007?
Give a very brief answer. 0.58. What is the ratio of the Aid flow from UN agencies (US$) of Small states in 2005 to that in 2006?
Your answer should be compact. 0.94. What is the ratio of the Aid flow from UN agencies (US$) in Kyrgyz Republic in 2005 to that in 2006?
Offer a terse response. 0.7. What is the ratio of the Aid flow from UN agencies (US$) in Malaysia in 2005 to that in 2006?
Provide a short and direct response. 1.11. What is the ratio of the Aid flow from UN agencies (US$) of Myanmar in 2005 to that in 2006?
Offer a very short reply. 0.98. What is the ratio of the Aid flow from UN agencies (US$) in Small states in 2005 to that in 2007?
Your response must be concise. 0.83. What is the ratio of the Aid flow from UN agencies (US$) in Kyrgyz Republic in 2005 to that in 2007?
Make the answer very short. 0.71. What is the ratio of the Aid flow from UN agencies (US$) in Malaysia in 2005 to that in 2007?
Make the answer very short. 0.66. What is the ratio of the Aid flow from UN agencies (US$) of Myanmar in 2005 to that in 2007?
Your answer should be very brief. 0.89. What is the ratio of the Aid flow from UN agencies (US$) in Small states in 2006 to that in 2007?
Make the answer very short. 0.88. What is the ratio of the Aid flow from UN agencies (US$) in Kyrgyz Republic in 2006 to that in 2007?
Provide a short and direct response. 1.02. What is the ratio of the Aid flow from UN agencies (US$) of Malaysia in 2006 to that in 2007?
Your answer should be very brief. 0.59. What is the ratio of the Aid flow from UN agencies (US$) of Myanmar in 2006 to that in 2007?
Your answer should be compact. 0.91. What is the difference between the highest and the second highest Aid flow from UN agencies (US$) in Small states?
Keep it short and to the point. 3.51e+06. What is the difference between the highest and the second highest Aid flow from UN agencies (US$) in Myanmar?
Your response must be concise. 1.23e+06. What is the difference between the highest and the lowest Aid flow from UN agencies (US$) of Small states?
Ensure brevity in your answer.  1.38e+07. What is the difference between the highest and the lowest Aid flow from UN agencies (US$) in Kyrgyz Republic?
Your answer should be very brief. 1.93e+06. What is the difference between the highest and the lowest Aid flow from UN agencies (US$) of Malaysia?
Provide a succinct answer. 7.10e+05. What is the difference between the highest and the lowest Aid flow from UN agencies (US$) of Myanmar?
Your answer should be very brief. 7.21e+06. 